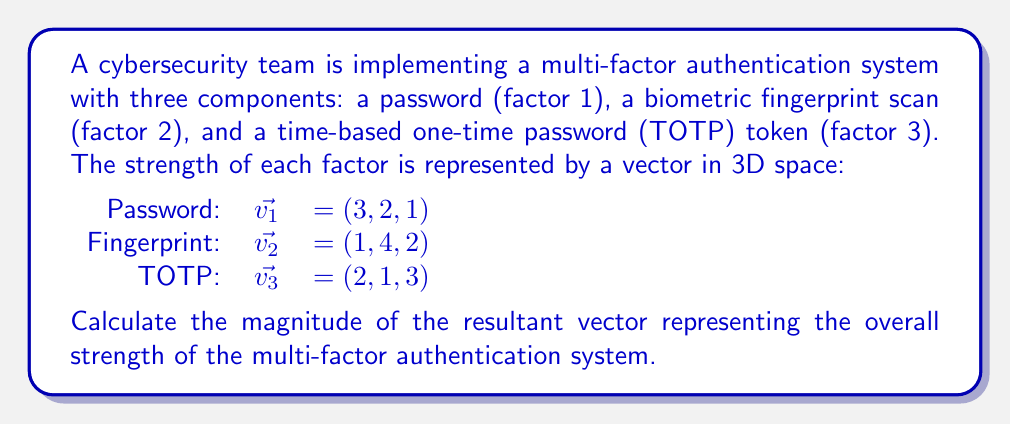Teach me how to tackle this problem. To solve this problem, we need to follow these steps:

1) First, we need to add the three vectors to get the resultant vector:
   $\vec{v_{resultant}} = \vec{v_1} + \vec{v_2} + \vec{v_3}$
   $\vec{v_{resultant}} = (3, 2, 1) + (1, 4, 2) + (2, 1, 3)$
   $\vec{v_{resultant}} = (3+1+2, 2+4+1, 1+2+3)$
   $\vec{v_{resultant}} = (6, 7, 6)$

2) Now that we have the resultant vector, we can calculate its magnitude. The magnitude of a vector $(x, y, z)$ is given by the formula:

   $\text{magnitude} = \sqrt{x^2 + y^2 + z^2}$

3) Let's substitute our values:
   $\text{magnitude} = \sqrt{6^2 + 7^2 + 6^2}$

4) Simplify:
   $\text{magnitude} = \sqrt{36 + 49 + 36}$
   $\text{magnitude} = \sqrt{121}$

5) Calculate the final result:
   $\text{magnitude} = 11$

Thus, the magnitude of the resultant vector representing the overall strength of the multi-factor authentication system is 11.
Answer: 11 